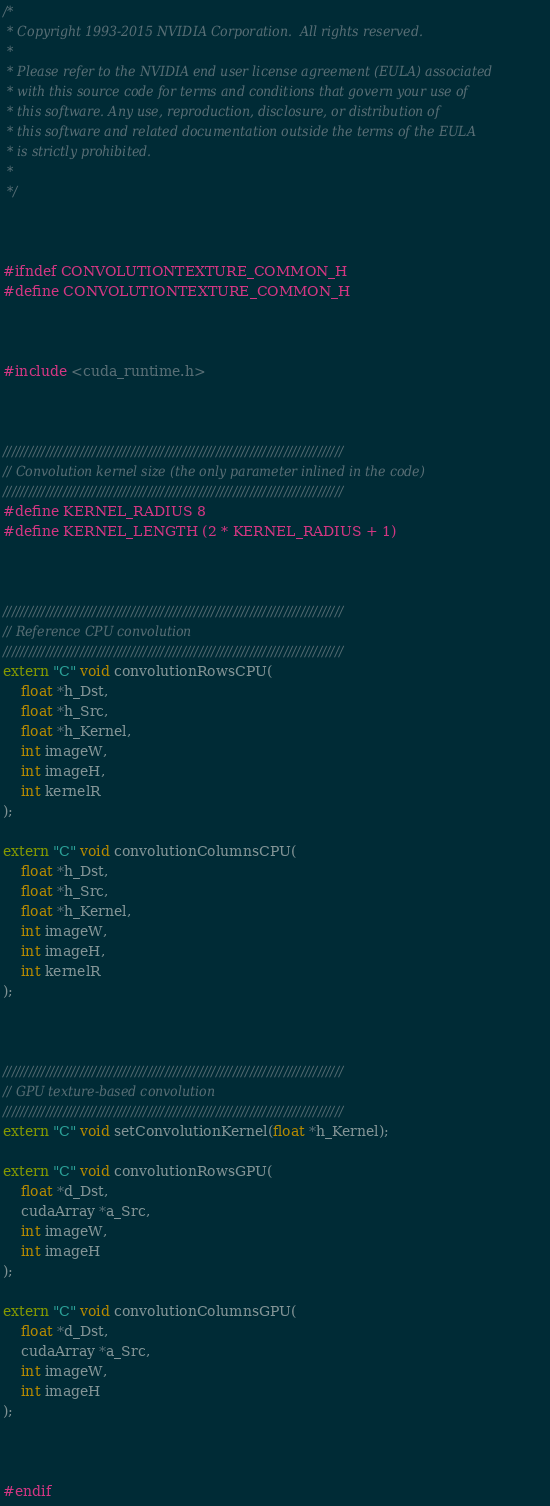<code> <loc_0><loc_0><loc_500><loc_500><_C_>/*
 * Copyright 1993-2015 NVIDIA Corporation.  All rights reserved.
 *
 * Please refer to the NVIDIA end user license agreement (EULA) associated
 * with this source code for terms and conditions that govern your use of
 * this software. Any use, reproduction, disclosure, or distribution of
 * this software and related documentation outside the terms of the EULA
 * is strictly prohibited.
 *
 */



#ifndef CONVOLUTIONTEXTURE_COMMON_H
#define CONVOLUTIONTEXTURE_COMMON_H



#include <cuda_runtime.h>



////////////////////////////////////////////////////////////////////////////////
// Convolution kernel size (the only parameter inlined in the code)
////////////////////////////////////////////////////////////////////////////////
#define KERNEL_RADIUS 8
#define KERNEL_LENGTH (2 * KERNEL_RADIUS + 1)



////////////////////////////////////////////////////////////////////////////////
// Reference CPU convolution
////////////////////////////////////////////////////////////////////////////////
extern "C" void convolutionRowsCPU(
    float *h_Dst,
    float *h_Src,
    float *h_Kernel,
    int imageW,
    int imageH,
    int kernelR
);

extern "C" void convolutionColumnsCPU(
    float *h_Dst,
    float *h_Src,
    float *h_Kernel,
    int imageW,
    int imageH,
    int kernelR
);



////////////////////////////////////////////////////////////////////////////////
// GPU texture-based convolution
////////////////////////////////////////////////////////////////////////////////
extern "C" void setConvolutionKernel(float *h_Kernel);

extern "C" void convolutionRowsGPU(
    float *d_Dst,
    cudaArray *a_Src,
    int imageW,
    int imageH
);

extern "C" void convolutionColumnsGPU(
    float *d_Dst,
    cudaArray *a_Src,
    int imageW,
    int imageH
);



#endif
</code> 